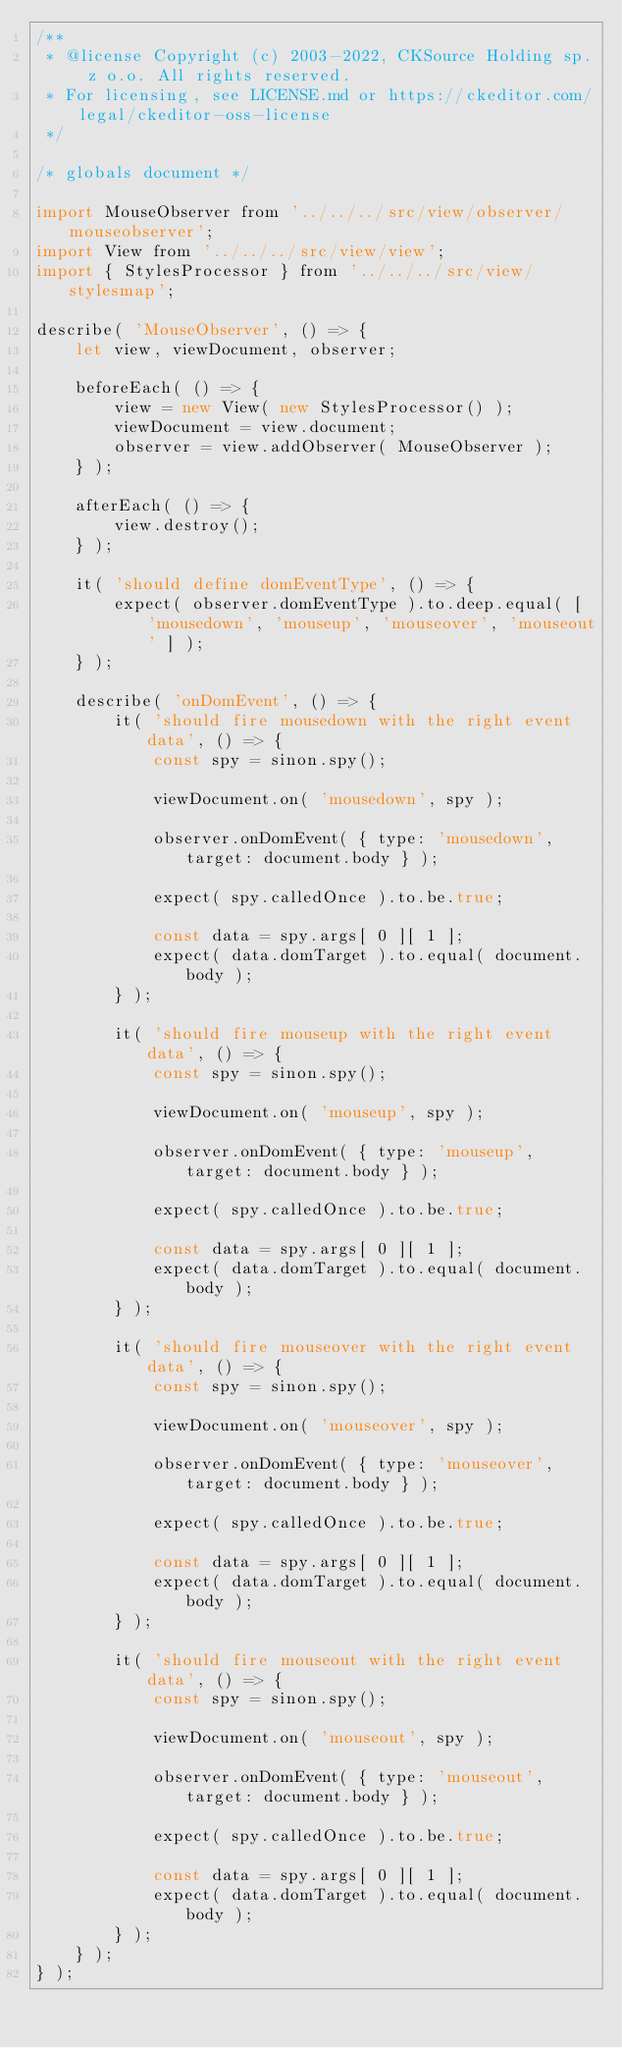Convert code to text. <code><loc_0><loc_0><loc_500><loc_500><_JavaScript_>/**
 * @license Copyright (c) 2003-2022, CKSource Holding sp. z o.o. All rights reserved.
 * For licensing, see LICENSE.md or https://ckeditor.com/legal/ckeditor-oss-license
 */

/* globals document */

import MouseObserver from '../../../src/view/observer/mouseobserver';
import View from '../../../src/view/view';
import { StylesProcessor } from '../../../src/view/stylesmap';

describe( 'MouseObserver', () => {
	let view, viewDocument, observer;

	beforeEach( () => {
		view = new View( new StylesProcessor() );
		viewDocument = view.document;
		observer = view.addObserver( MouseObserver );
	} );

	afterEach( () => {
		view.destroy();
	} );

	it( 'should define domEventType', () => {
		expect( observer.domEventType ).to.deep.equal( [ 'mousedown', 'mouseup', 'mouseover', 'mouseout' ] );
	} );

	describe( 'onDomEvent', () => {
		it( 'should fire mousedown with the right event data', () => {
			const spy = sinon.spy();

			viewDocument.on( 'mousedown', spy );

			observer.onDomEvent( { type: 'mousedown', target: document.body } );

			expect( spy.calledOnce ).to.be.true;

			const data = spy.args[ 0 ][ 1 ];
			expect( data.domTarget ).to.equal( document.body );
		} );

		it( 'should fire mouseup with the right event data', () => {
			const spy = sinon.spy();

			viewDocument.on( 'mouseup', spy );

			observer.onDomEvent( { type: 'mouseup', target: document.body } );

			expect( spy.calledOnce ).to.be.true;

			const data = spy.args[ 0 ][ 1 ];
			expect( data.domTarget ).to.equal( document.body );
		} );

		it( 'should fire mouseover with the right event data', () => {
			const spy = sinon.spy();

			viewDocument.on( 'mouseover', spy );

			observer.onDomEvent( { type: 'mouseover', target: document.body } );

			expect( spy.calledOnce ).to.be.true;

			const data = spy.args[ 0 ][ 1 ];
			expect( data.domTarget ).to.equal( document.body );
		} );

		it( 'should fire mouseout with the right event data', () => {
			const spy = sinon.spy();

			viewDocument.on( 'mouseout', spy );

			observer.onDomEvent( { type: 'mouseout', target: document.body } );

			expect( spy.calledOnce ).to.be.true;

			const data = spy.args[ 0 ][ 1 ];
			expect( data.domTarget ).to.equal( document.body );
		} );
	} );
} );
</code> 